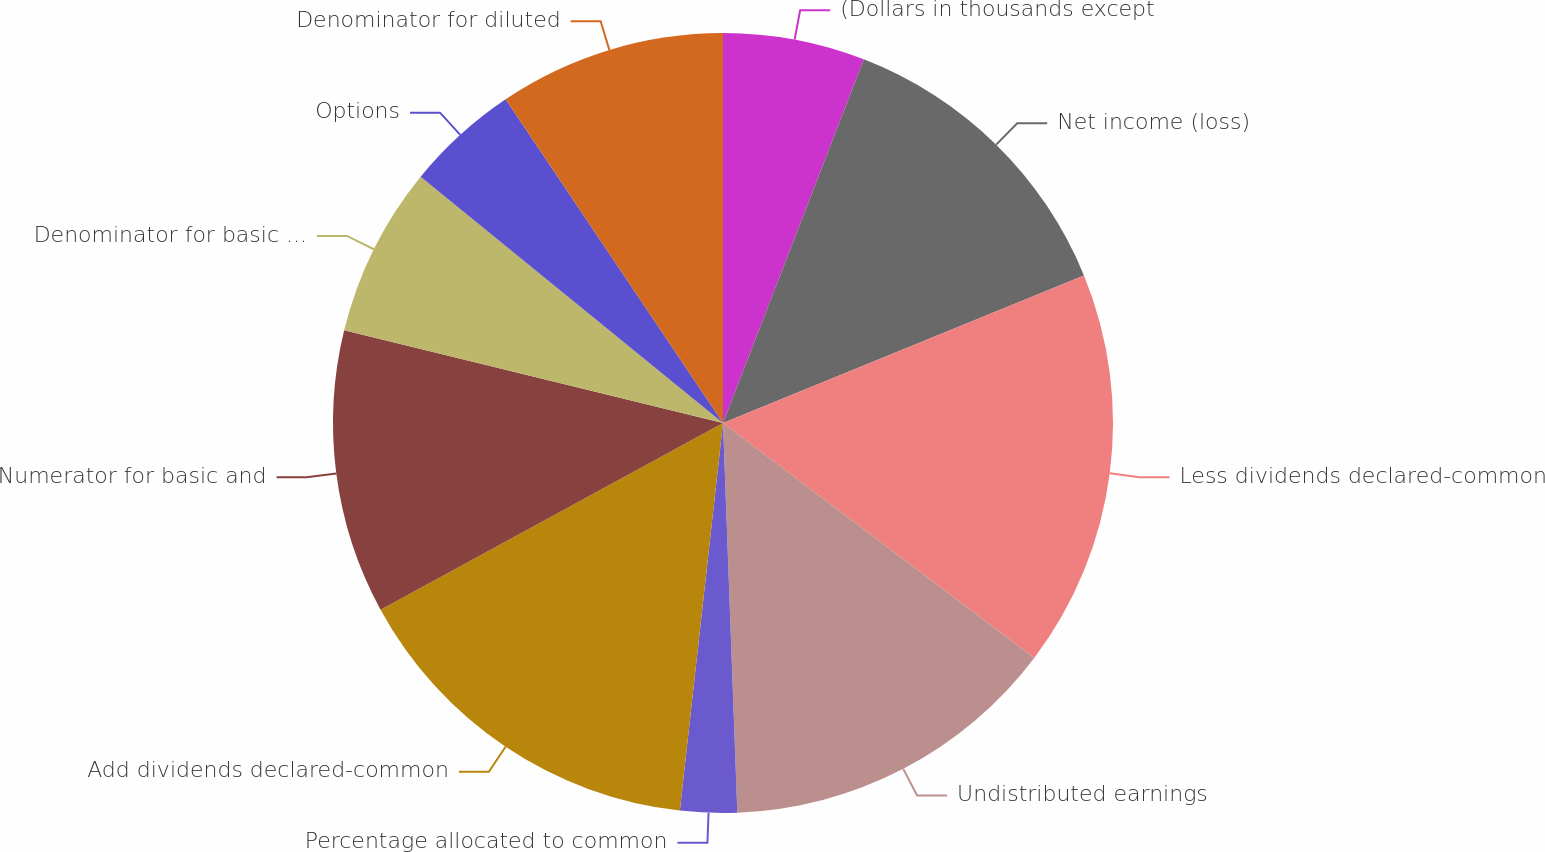<chart> <loc_0><loc_0><loc_500><loc_500><pie_chart><fcel>(Dollars in thousands except<fcel>Net income (loss)<fcel>Less dividends declared-common<fcel>Undistributed earnings<fcel>Percentage allocated to common<fcel>Add dividends declared-common<fcel>Numerator for basic and<fcel>Denominator for basic earnings<fcel>Options<fcel>Denominator for diluted<nl><fcel>5.88%<fcel>12.94%<fcel>16.47%<fcel>14.12%<fcel>2.35%<fcel>15.29%<fcel>11.76%<fcel>7.06%<fcel>4.71%<fcel>9.41%<nl></chart> 